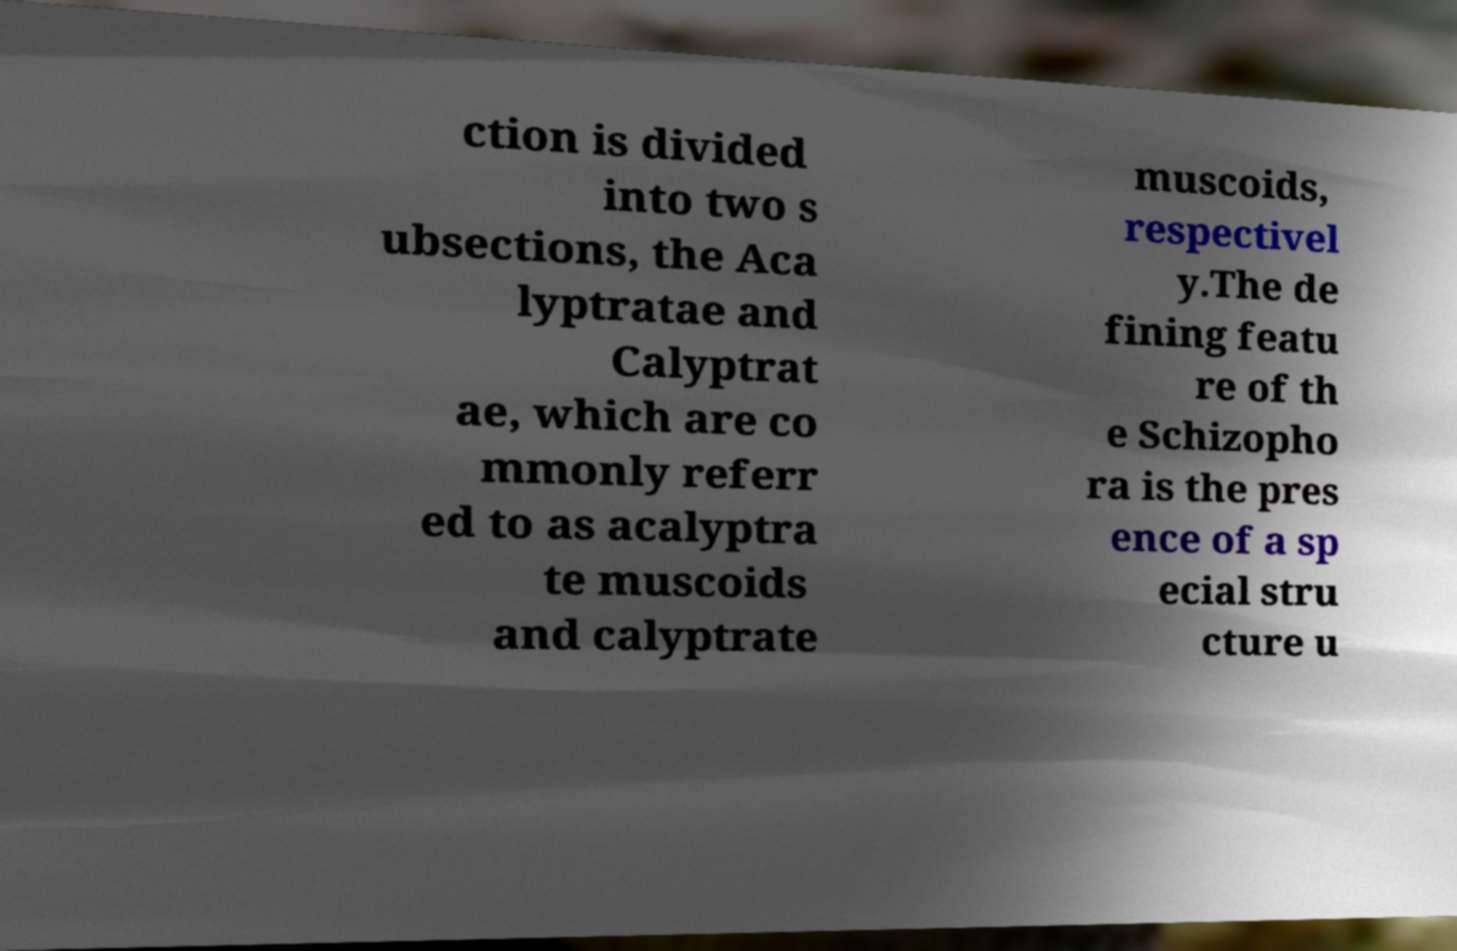Please identify and transcribe the text found in this image. ction is divided into two s ubsections, the Aca lyptratae and Calyptrat ae, which are co mmonly referr ed to as acalyptra te muscoids and calyptrate muscoids, respectivel y.The de fining featu re of th e Schizopho ra is the pres ence of a sp ecial stru cture u 